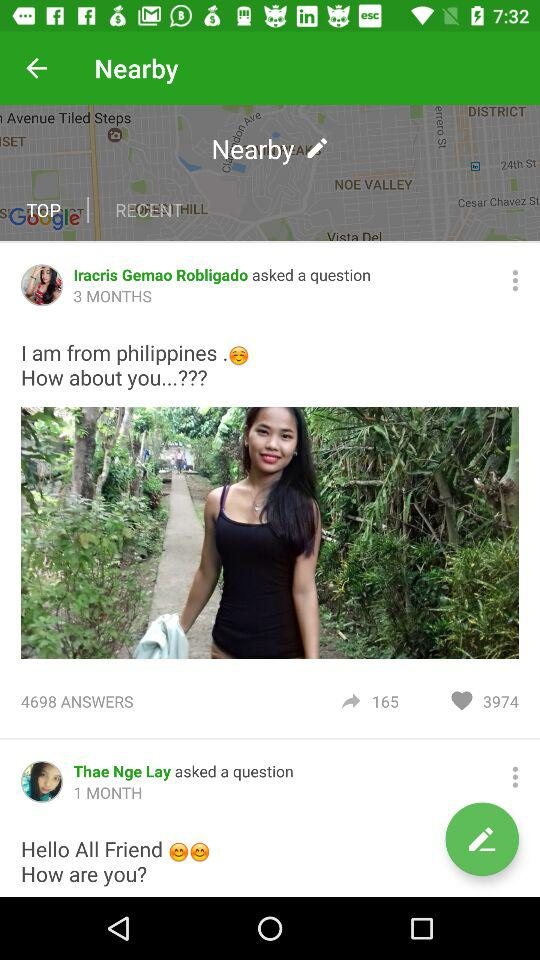When did "Iracris Gemao Robligado" ask a question? "Iracris Gemao Robligado" asked a question 3 months ago. 